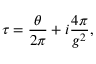<formula> <loc_0><loc_0><loc_500><loc_500>\tau = \frac { \theta } { 2 \pi } + i \frac { 4 \pi } { g ^ { 2 } } ,</formula> 